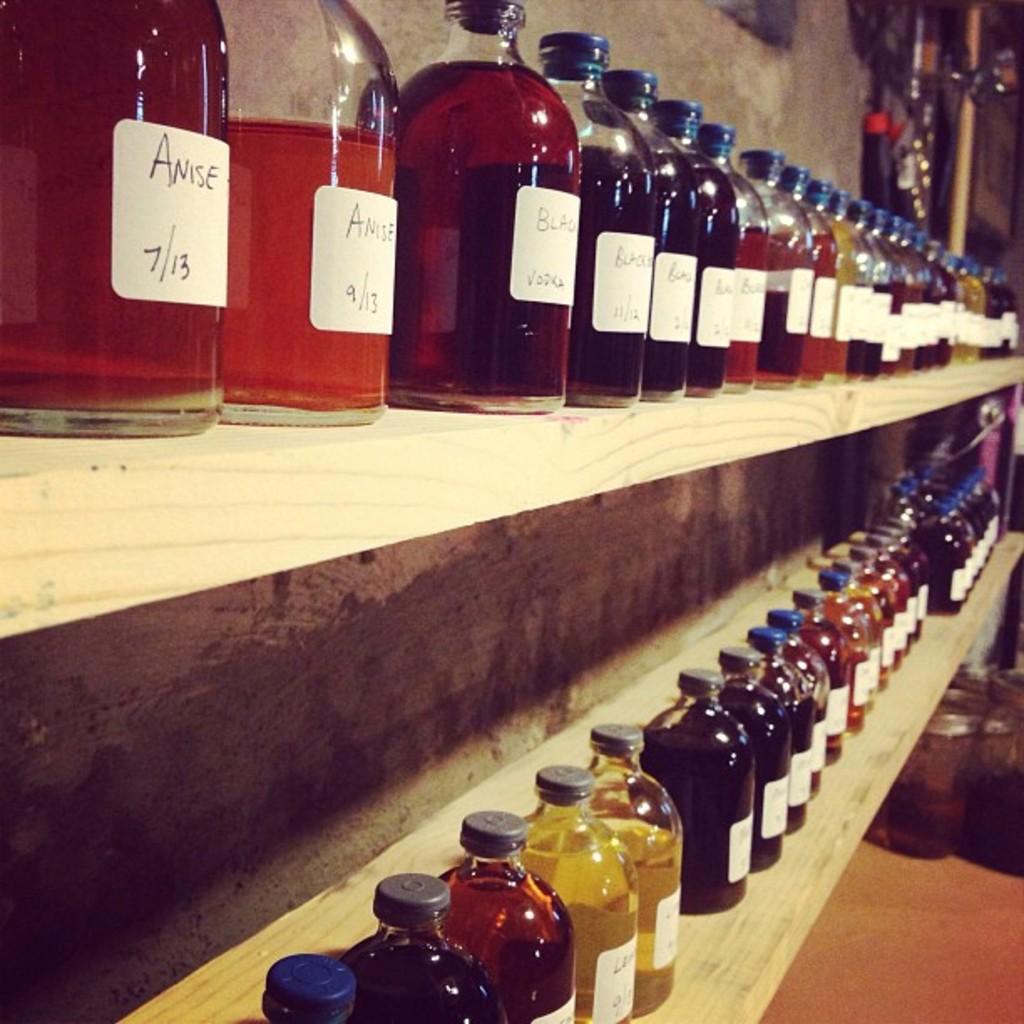Does the second bottle say 9/13?
Your answer should be very brief. Yes. 